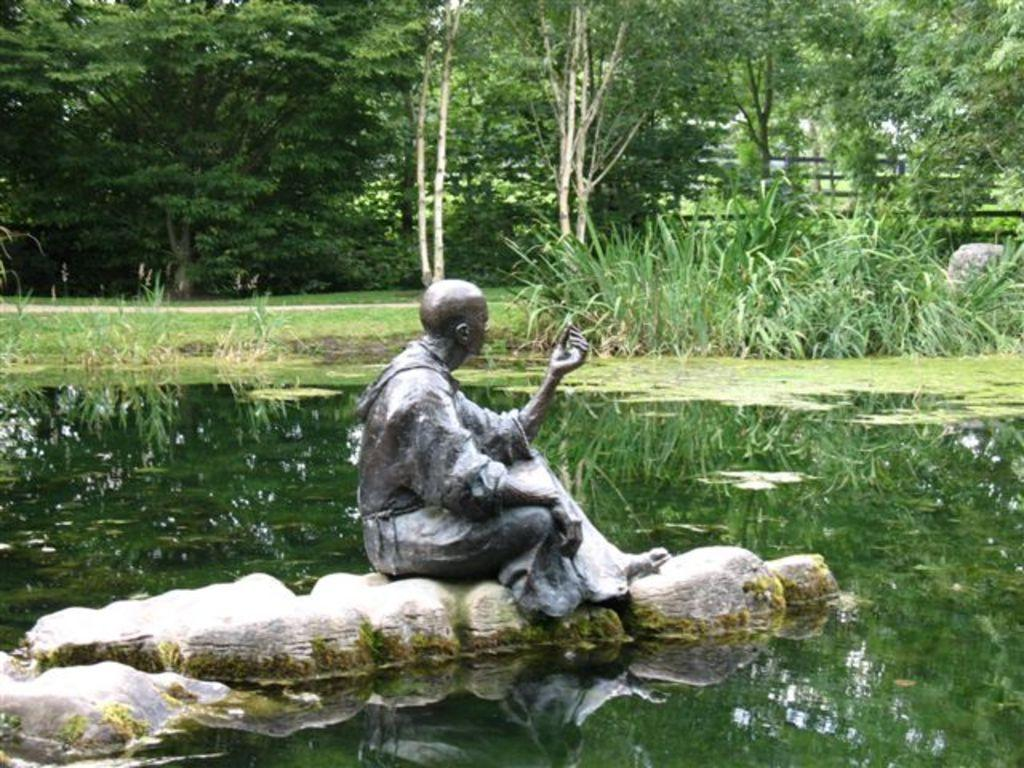What is the main subject of the image? There is a statue of a person in the image. What can be seen in the background of the image? There are plants, water, and trees visible in the background of the image. What type of oven is used to cook the plants in the image? There is no oven present in the image, and plants are not being cooked. 